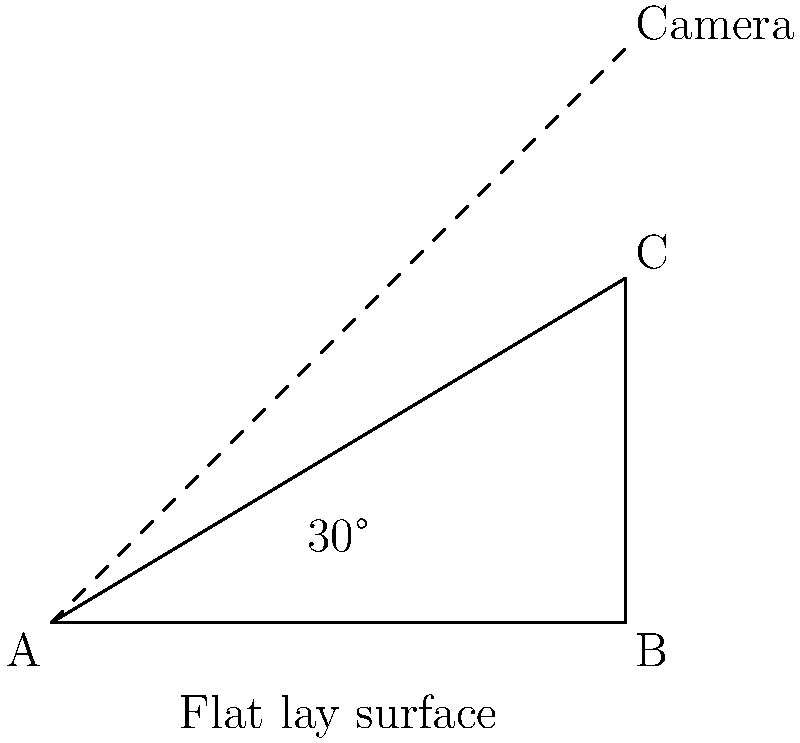Per creare una composizione flat lay perfetta per i tuoi post su Instagram, devi posizionare la fotocamera con un angolo di inclinazione specifico rispetto alla superficie. Se l'angolo tra la superficie e la linea di vista della fotocamera è di 30°, qual è l'angolo di inclinazione della fotocamera rispetto alla verticale per ottenere lo scatto migliore? Per risolvere questo problema, seguiamo questi passaggi:

1) Osserviamo che l'angolo tra la superficie piatta e la linea di vista della fotocamera è di 30°.

2) In un triangolo rettangolo, la somma degli angoli interni è sempre 180°.

3) Uno degli angoli del triangolo rettangolo è sempre 90° (l'angolo retto).

4) Quindi, possiamo calcolare l'angolo rimanente sottraendo gli altri due angoli da 180°:

   $$180° - 90° - 30° = 60°$$

5) Questo angolo di 60° è l'angolo tra la linea di vista della fotocamera e la verticale.

6) L'angolo di inclinazione della fotocamera rispetto alla verticale è quindi 60°.

Questo angolo di 60° creerà una composizione flat lay esteticamente piacevole, ideale per i tuoi post su Instagram e per aumentare il tuo seguito sui social media.
Answer: 60° 